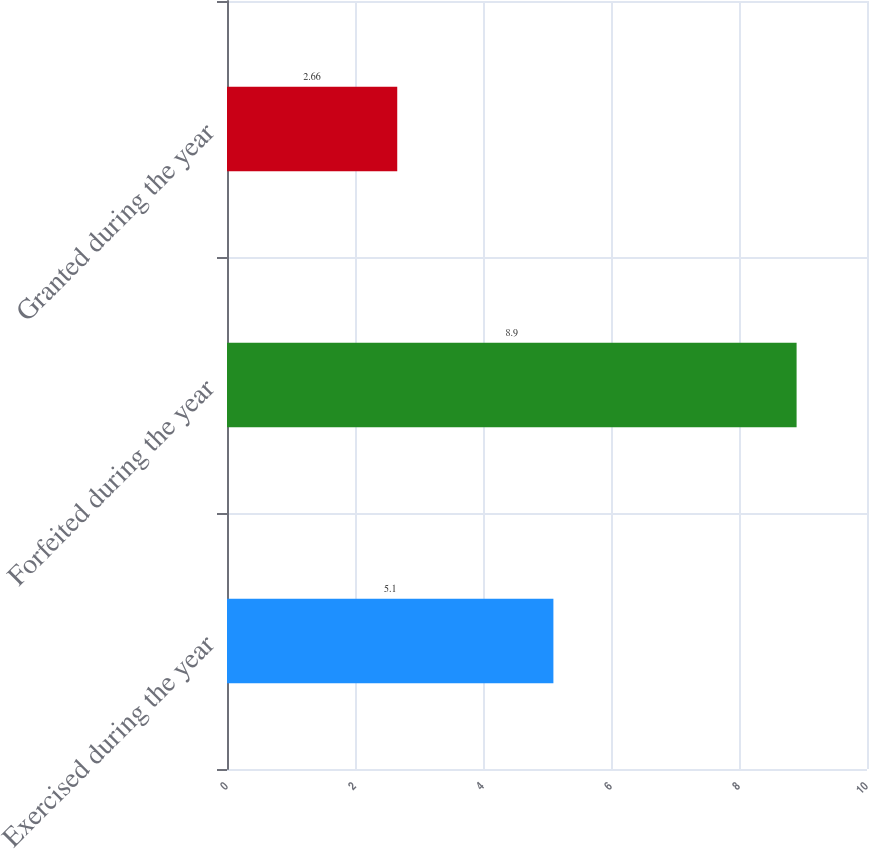Convert chart to OTSL. <chart><loc_0><loc_0><loc_500><loc_500><bar_chart><fcel>Exercised during the year<fcel>Forfeited during the year<fcel>Granted during the year<nl><fcel>5.1<fcel>8.9<fcel>2.66<nl></chart> 